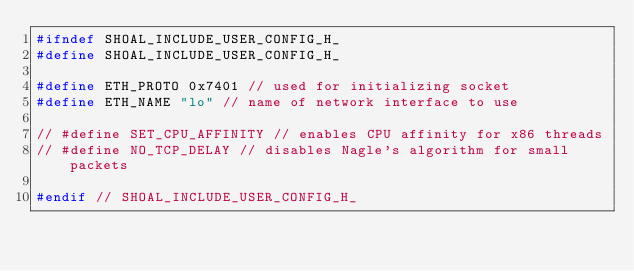Convert code to text. <code><loc_0><loc_0><loc_500><loc_500><_C++_>#ifndef SHOAL_INCLUDE_USER_CONFIG_H_
#define SHOAL_INCLUDE_USER_CONFIG_H_

#define ETH_PROTO 0x7401 // used for initializing socket
#define ETH_NAME "lo" // name of network interface to use

// #define SET_CPU_AFFINITY // enables CPU affinity for x86 threads
// #define NO_TCP_DELAY // disables Nagle's algorithm for small packets

#endif // SHOAL_INCLUDE_USER_CONFIG_H_
</code> 